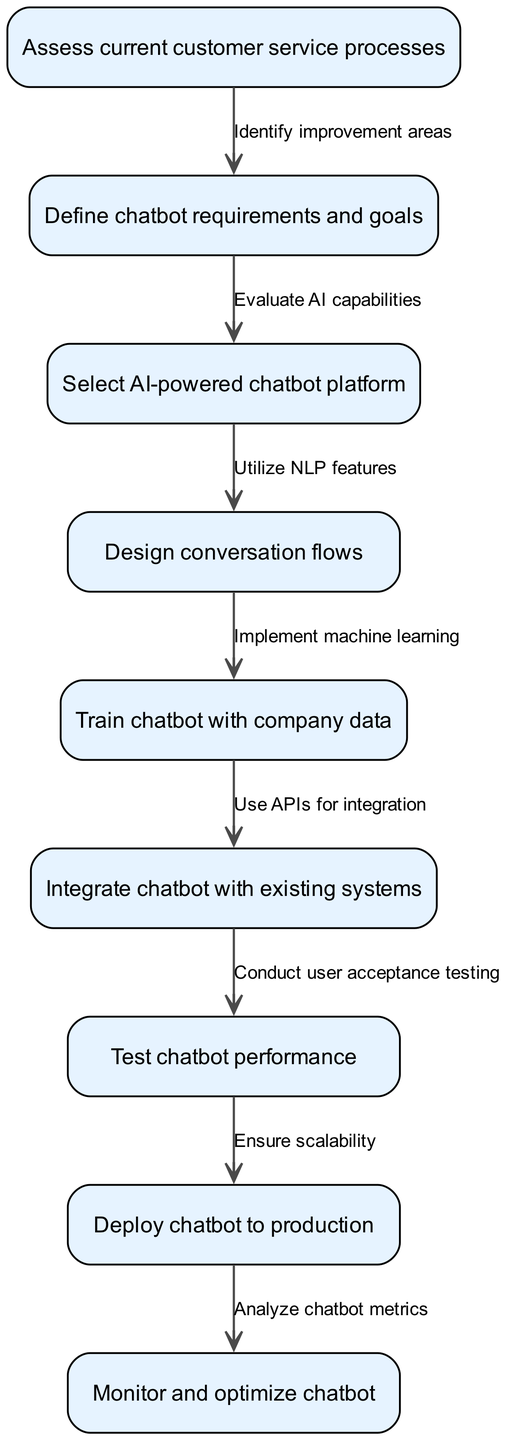What is the first step in the chatbot implementation workflow? The first step, represented by node 1, is to "Assess current customer service processes." This indicates the initial action required before proceeding with the subsequent tasks.
Answer: Assess current customer service processes How many nodes are in the flow chart? By counting the entries in the "nodes" section of the data, we find a total of 9 nodes present in the diagram. Each node represents a specific action or step in the workflow.
Answer: 9 What is the relationship between defining chatbot requirements and selecting a chatbot platform? The edge going from node 2 ("Define chatbot requirements and goals") to node 3 ("Select AI-powered chatbot platform") indicates this relationship, showing that once requirements are defined, it is essential to select a suitable platform meeting those requirements.
Answer: Evaluate AI capabilities What comes after testing the chatbot performance? The edge from node 7 ("Test chatbot performance") to node 8 ("Deploy chatbot to production") shows the next step after the testing phase. It shows that once testing is done, the chatbot is ready to be deployed.
Answer: Deploy chatbot to production What is the last step in the workflow? The last action in the sequence, represented by node 9, is to "Monitor and optimize chatbot," highlighting the ongoing nature of chatbot management after deployment.
Answer: Monitor and optimize chatbot What must happen before integrating the chatbot with existing systems? The edge from node 5 ("Train chatbot with company data") to node 6 ("Integrate chatbot with existing systems") clarifies that training must be completed before moving on to integration, ensuring the chatbot has the necessary information.
Answer: Train chatbot with company data Which node describes ensuring scalability? Node 7 leads directly to node 8, which is "Deploy chatbot to production." However, the text on the edge states "Ensure scalability," suggesting this is considered right before moving into production.
Answer: Ensure scalability How does designing conversation flows relate to training the chatbot? The relationship is indicated by the edge connecting node 4 ("Design conversation flows") to node 5 ("Train chatbot with company data"). This shows that the design of conversation flows is essential to the chatbot's training phase since it provides the structure for training.
Answer: Implement machine learning 